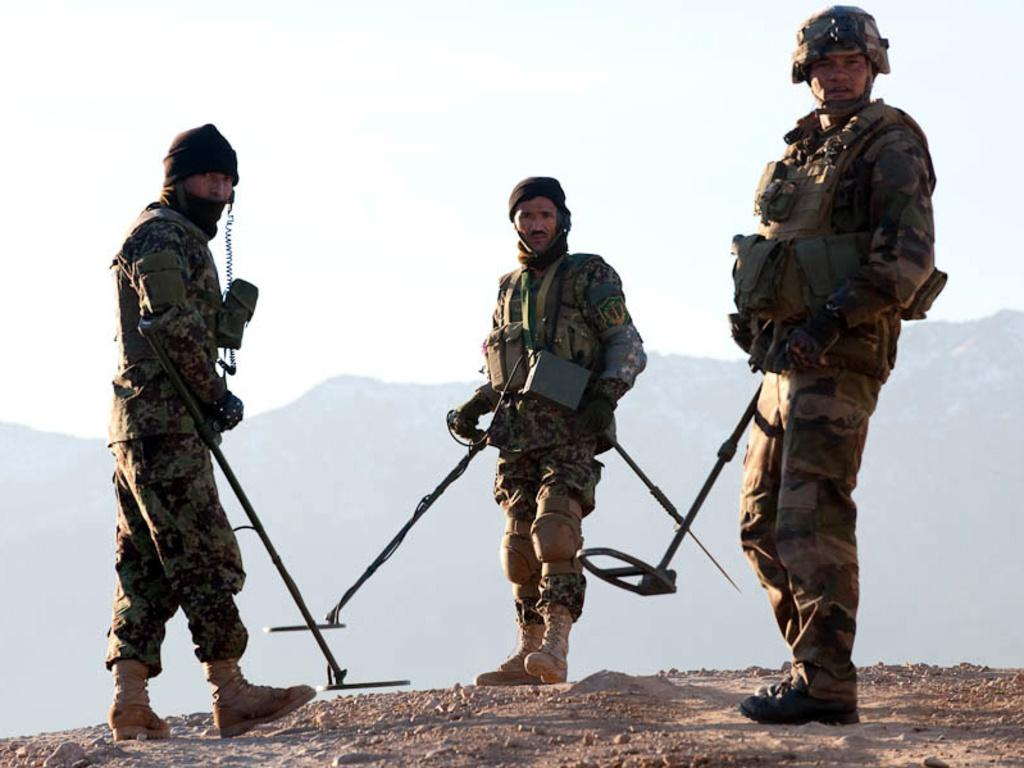How many people are present in the image? There are three people in the image. What are the people doing in the image? The people are standing on the ground. What are the people holding in the image? The people are holding objects. What can be seen in the background of the image? There are mountains and the sky visible in the background of the image. What type of fowl can be seen walking rhythmically in the image? There is no fowl present in the image, and therefore no such activity can be observed. Is there a door visible in the image? There is no door present in the image. 